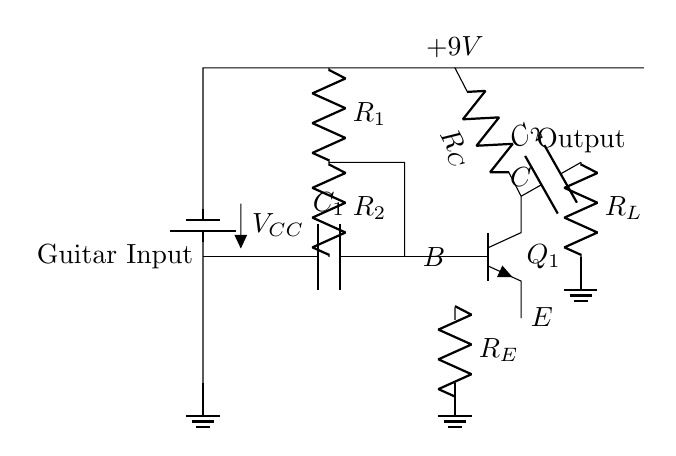What is the type of the first component connected to the guitar input? The first component connected to the guitar input is a capacitor, labeled as C1 in the circuit. It functions to block DC while allowing AC signals from the guitar to pass through.
Answer: Capacitor What is the function of R1 and R2 together in this circuit? R1 and R2 form a voltage divider that sets the biasing voltage for the base of the transistor Q1, ensuring it operates in the active region for amplification.
Answer: Voltage divider What is the value of the supply voltage in the circuit? The supply voltage is indicated in the circuit as +9V, which provides the necessary power for the operation of the amplifier.
Answer: 9V What is the significance of the output capacitor C2 in the circuit? The output capacitor C2 is critical as it blocks any DC component of the output signal while allowing the amplified AC signal from the transistor to pass to the load, represented by R_L.
Answer: Blocks DC How does the emitter resistor R_E influence the amplifier's performance? The emitter resistor R_E provides negative feedback, stabilizing the operating point of the transistor Q1, which improves linearity and reduces distortion in the amplified signal.
Answer: Stabilizes operating point What is the role of the transistor Q1 in this circuit? The transistor Q1 acts as the main amplifying component, taking the small input signal from the guitar and increasing its amplitude, allowing it to drive larger loads like speakers.
Answer: Amplifier 